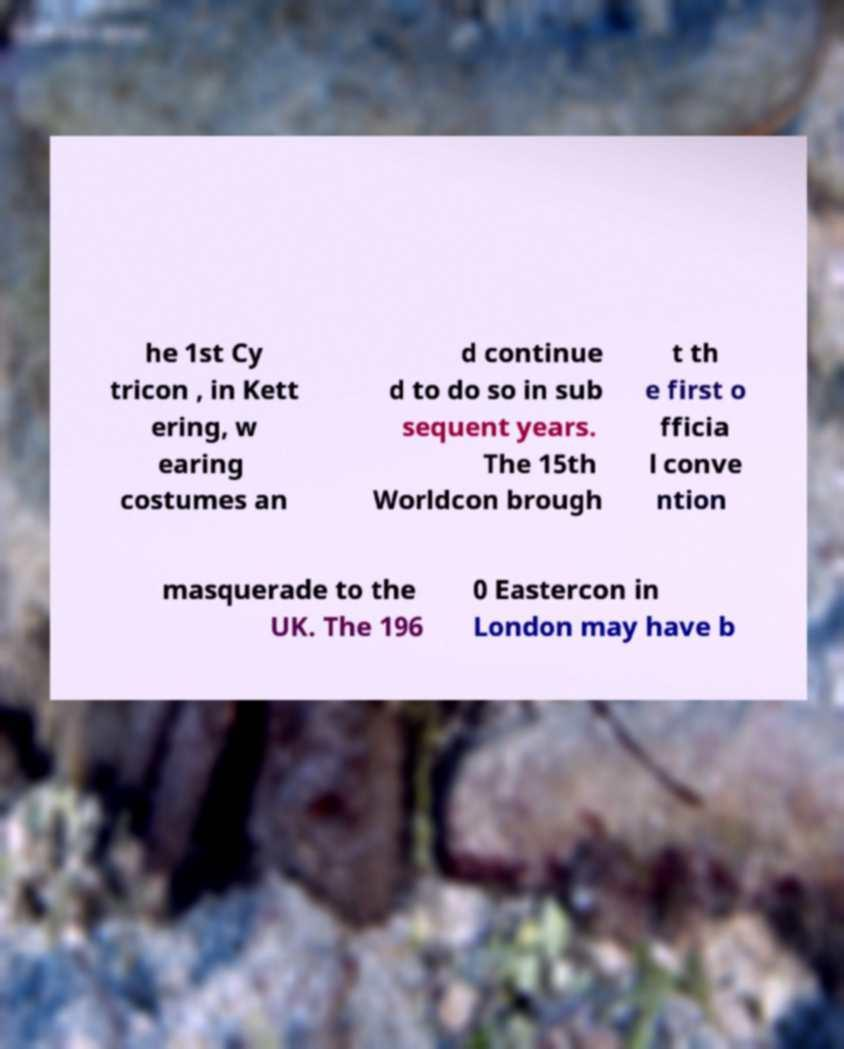Could you assist in decoding the text presented in this image and type it out clearly? he 1st Cy tricon , in Kett ering, w earing costumes an d continue d to do so in sub sequent years. The 15th Worldcon brough t th e first o fficia l conve ntion masquerade to the UK. The 196 0 Eastercon in London may have b 